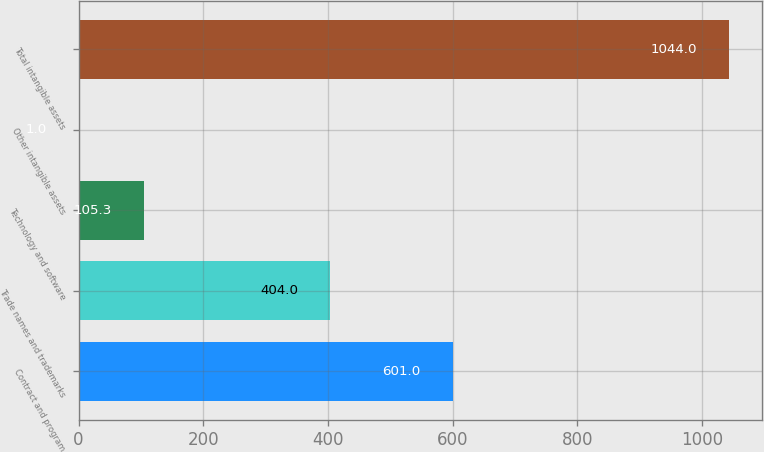Convert chart to OTSL. <chart><loc_0><loc_0><loc_500><loc_500><bar_chart><fcel>Contract and program<fcel>Trade names and trademarks<fcel>Technology and software<fcel>Other intangible assets<fcel>Total intangible assets<nl><fcel>601<fcel>404<fcel>105.3<fcel>1<fcel>1044<nl></chart> 